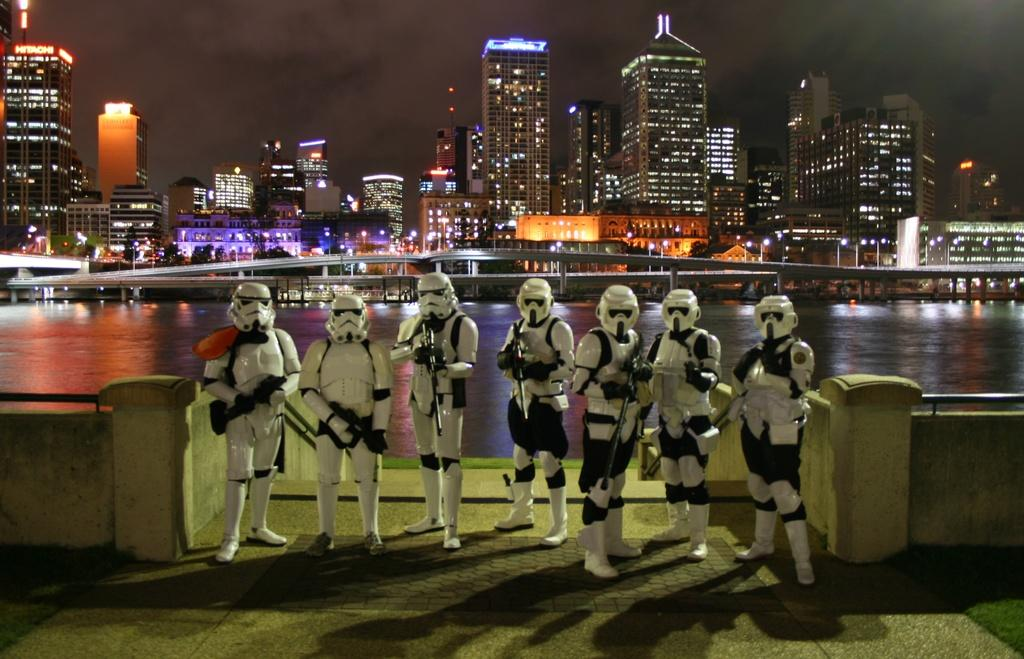What are the persons in the image wearing? The persons in the image are wearing costumes. What are the persons holding in their hands? The persons are holding rifles in their hands. What can be seen in the background of the image? There is a river, skyscrapers, buildings, electric lights, and the sky visible in the background of the image. How far away is the plant from the persons in the image? There is no plant present in the image, so it is not possible to determine the distance between a plant and the persons. 